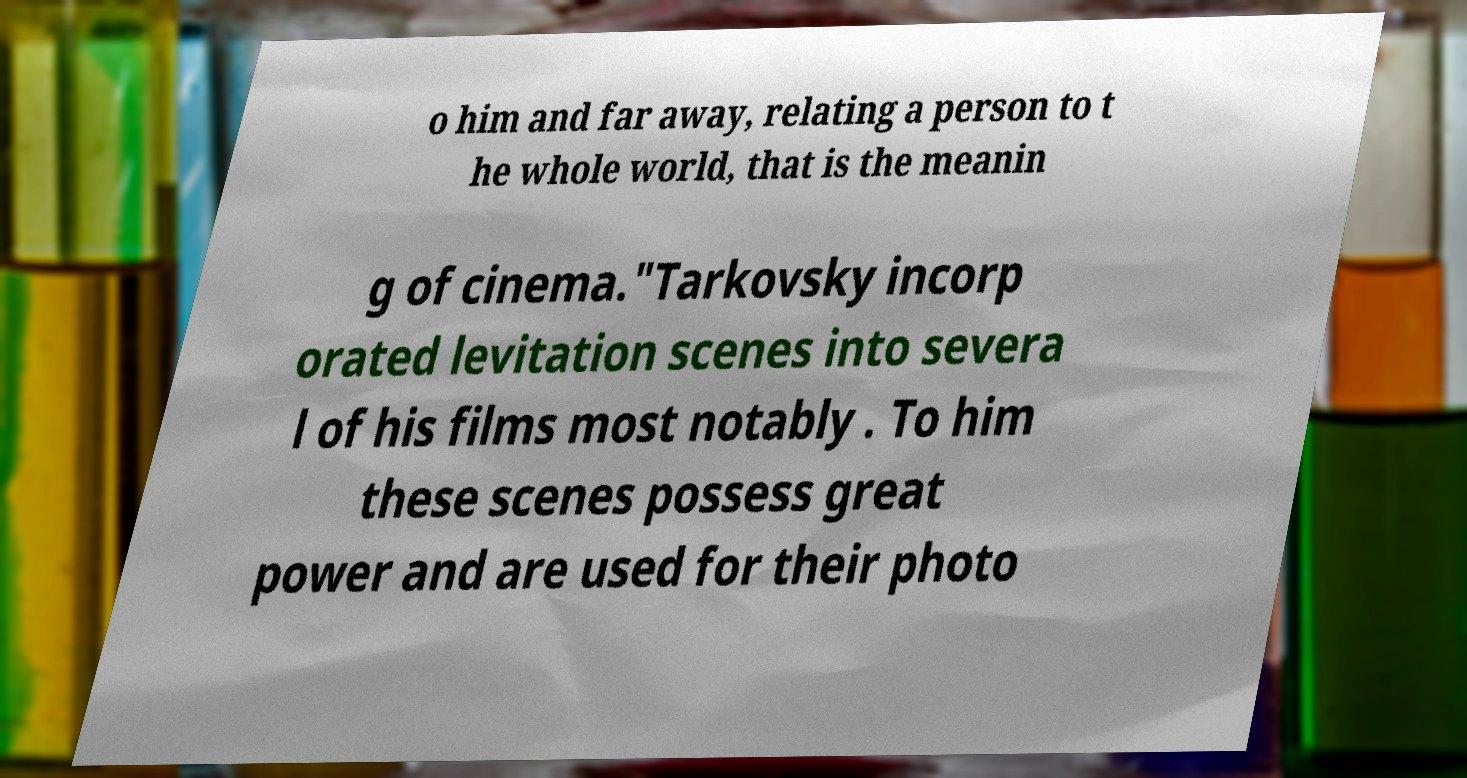I need the written content from this picture converted into text. Can you do that? o him and far away, relating a person to t he whole world, that is the meanin g of cinema."Tarkovsky incorp orated levitation scenes into severa l of his films most notably . To him these scenes possess great power and are used for their photo 